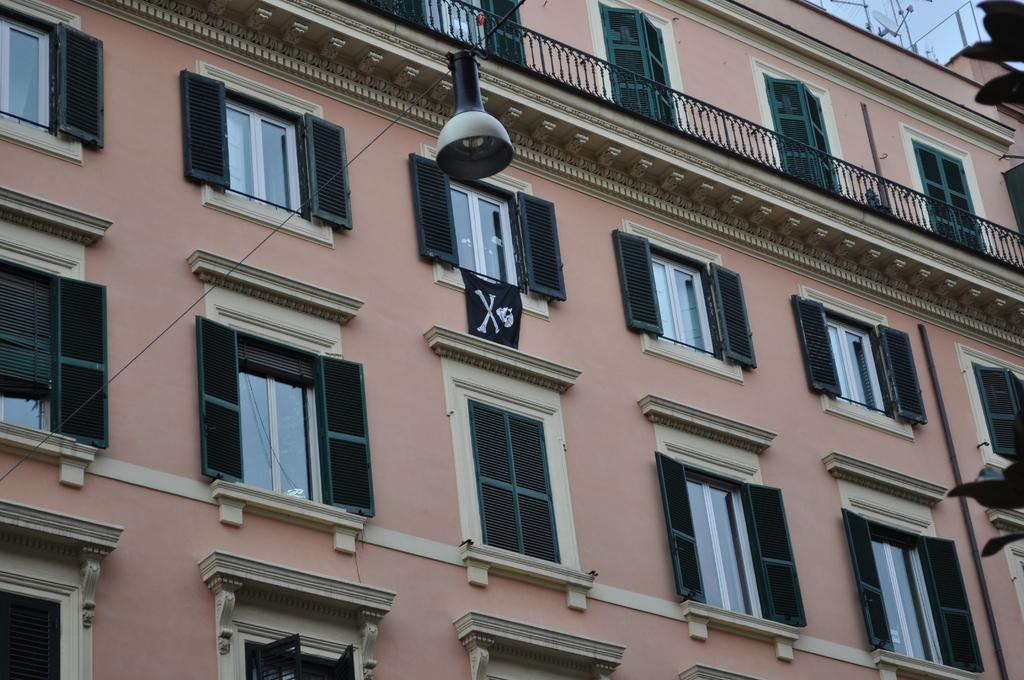What type of structure is visible in the image? There is a building in the image. What feature of the building is mentioned in the facts? The building has multiple windows. Can you describe any other objects or features in the image? There is a light attached to a rope in the image. How many pigs are visible in the image? There are no pigs present in the image. What emotion can be seen on the pigs' faces in the image? There are no pigs in the image, so it is impossible to determine their emotions. 